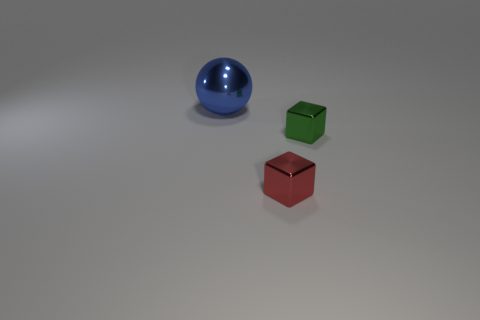Are there any other things that are the same size as the blue sphere?
Make the answer very short. No. How many small blocks are there?
Your answer should be compact. 2. Do the block that is behind the tiny red cube and the small red thing have the same material?
Keep it short and to the point. Yes. Are there any other things that are the same material as the tiny red block?
Offer a terse response. Yes. How many big things are in front of the cube that is in front of the metallic block right of the red shiny block?
Provide a short and direct response. 0. How big is the green metallic object?
Make the answer very short. Small. There is a cube on the left side of the tiny green shiny block; how big is it?
Ensure brevity in your answer.  Small. Does the metallic cube in front of the green shiny block have the same color as the thing behind the small green metallic cube?
Your answer should be very brief. No. How many other things are the same shape as the big object?
Offer a very short reply. 0. Are there an equal number of red metallic cubes that are right of the tiny green shiny thing and tiny shiny objects on the right side of the small red shiny thing?
Give a very brief answer. No. 